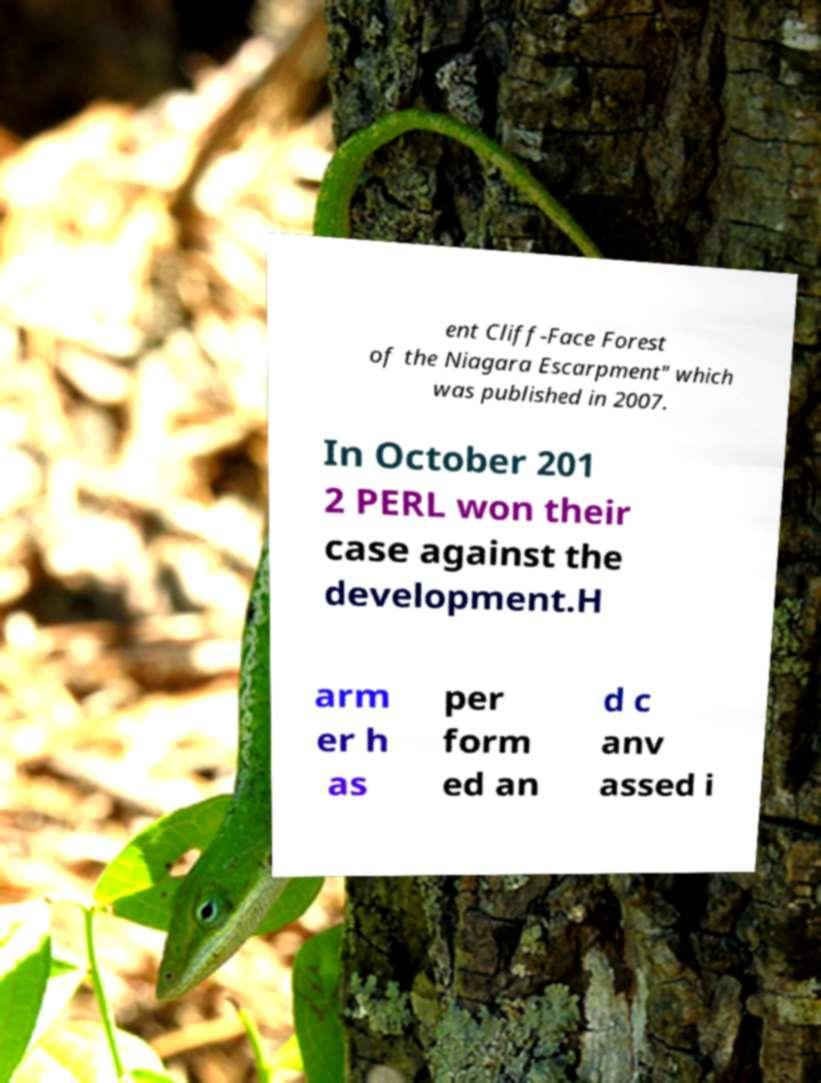I need the written content from this picture converted into text. Can you do that? ent Cliff-Face Forest of the Niagara Escarpment" which was published in 2007. In October 201 2 PERL won their case against the development.H arm er h as per form ed an d c anv assed i 